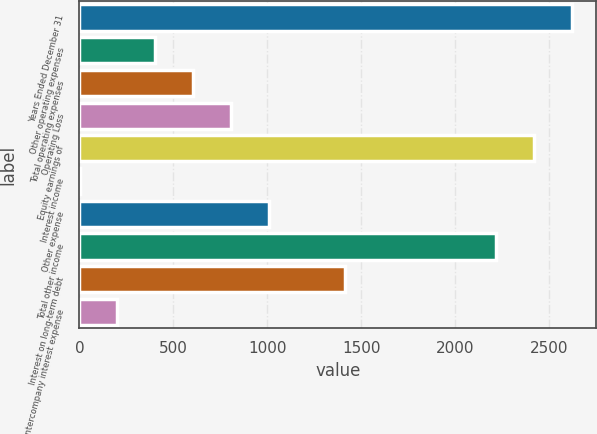<chart> <loc_0><loc_0><loc_500><loc_500><bar_chart><fcel>Years Ended December 31<fcel>Other operating expenses<fcel>Total operating expenses<fcel>Operating Loss<fcel>Equity earnings of<fcel>Interest income<fcel>Other expense<fcel>Total other income<fcel>Interest on long-term debt<fcel>Intercompany interest expense<nl><fcel>2620.5<fcel>404<fcel>605.5<fcel>807<fcel>2419<fcel>1<fcel>1008.5<fcel>2217.5<fcel>1411.5<fcel>202.5<nl></chart> 